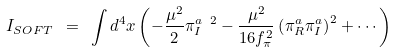Convert formula to latex. <formula><loc_0><loc_0><loc_500><loc_500>I _ { S O F T } \ = \ \int d ^ { 4 } x \left ( - \frac { \mu ^ { 2 } } { 2 } \pi ^ { a \ 2 } _ { I } - \frac { \mu ^ { 2 } } { 1 6 f _ { \pi } ^ { 2 } } \left ( \pi ^ { a } _ { R } \pi ^ { a } _ { I } \right ) ^ { 2 } + \cdots \right )</formula> 